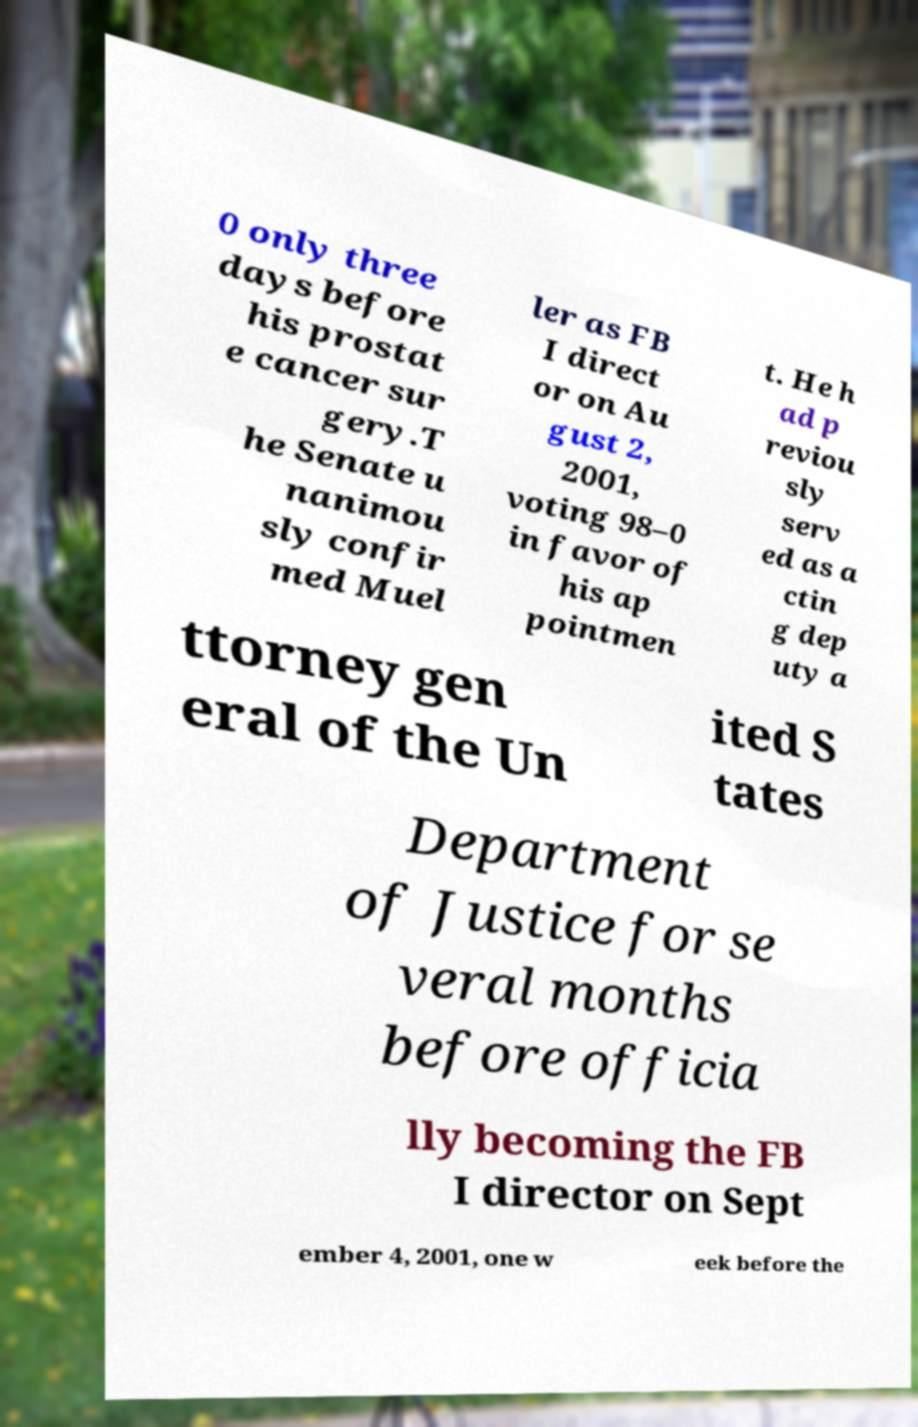There's text embedded in this image that I need extracted. Can you transcribe it verbatim? 0 only three days before his prostat e cancer sur gery.T he Senate u nanimou sly confir med Muel ler as FB I direct or on Au gust 2, 2001, voting 98–0 in favor of his ap pointmen t. He h ad p reviou sly serv ed as a ctin g dep uty a ttorney gen eral of the Un ited S tates Department of Justice for se veral months before officia lly becoming the FB I director on Sept ember 4, 2001, one w eek before the 